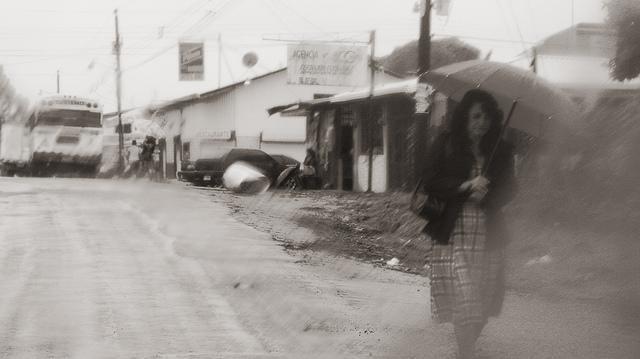How many giraffes are there?
Give a very brief answer. 0. 